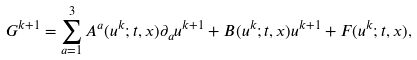<formula> <loc_0><loc_0><loc_500><loc_500>G ^ { k + 1 } = \sum _ { a = 1 } ^ { 3 } A ^ { a } ( u ^ { k } ; t , x ) \partial _ { a } u ^ { k + 1 } + B ( u ^ { k } ; t , x ) u ^ { k + 1 } + F ( u ^ { k } ; t , x ) ,</formula> 